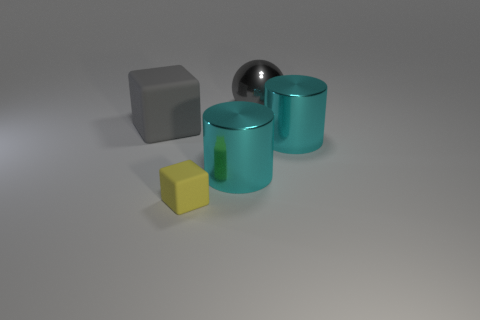Add 1 big metal things. How many objects exist? 6 Subtract all balls. How many objects are left? 4 Subtract all purple cylinders. Subtract all large metallic balls. How many objects are left? 4 Add 1 gray objects. How many gray objects are left? 3 Add 3 big gray blocks. How many big gray blocks exist? 4 Subtract 0 yellow spheres. How many objects are left? 5 